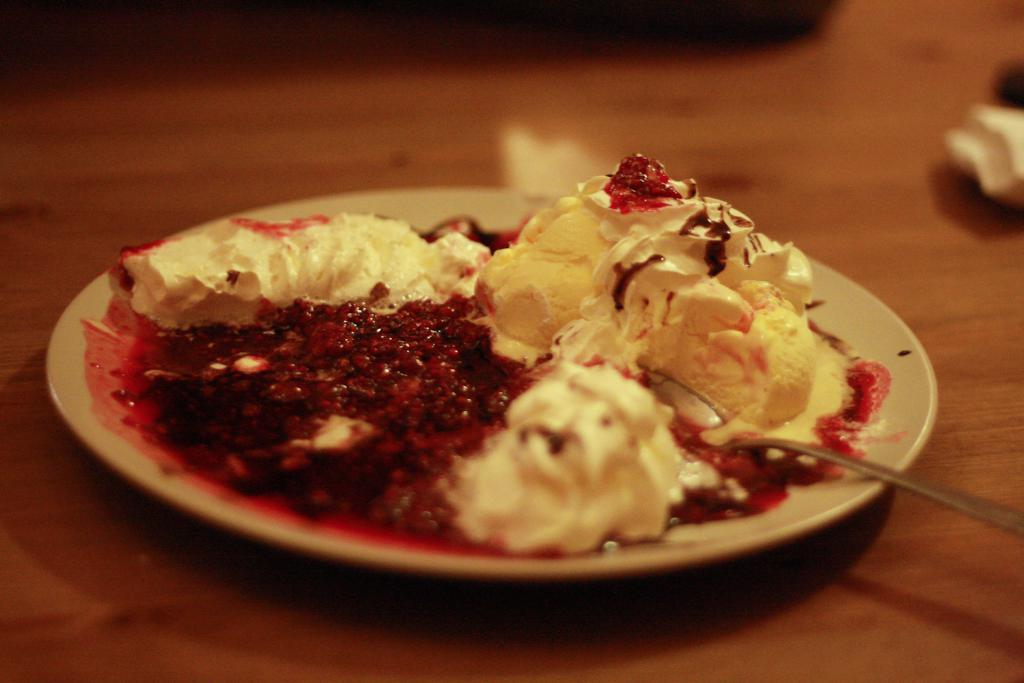What piece of furniture is present in the image? There is a table in the image. What is placed on the table? There is a plate on the table. What is on the plate? There are ice creams on the plate. What utensil is present on the plate? There is a spoon on the plate. Is there a spy observing the ice creams on the plate in the image? There is no indication of a spy or any surveillance activity in the image. 